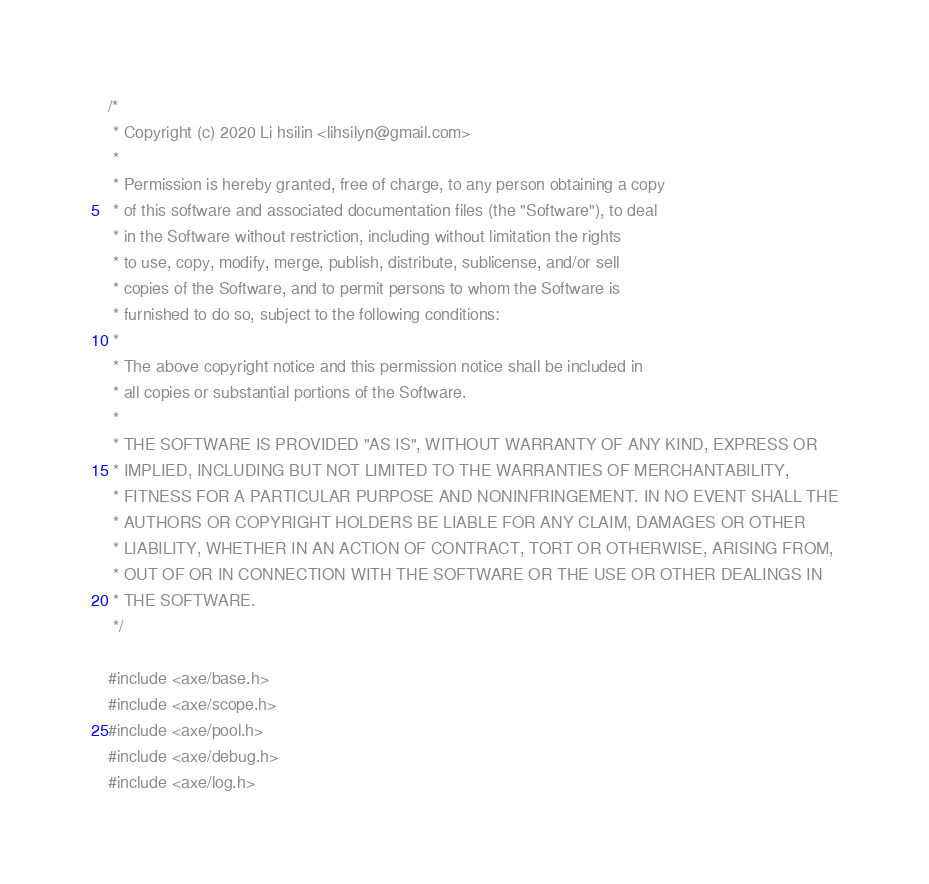Convert code to text. <code><loc_0><loc_0><loc_500><loc_500><_C_>/*
 * Copyright (c) 2020 Li hsilin <lihsilyn@gmail.com>
 *
 * Permission is hereby granted, free of charge, to any person obtaining a copy
 * of this software and associated documentation files (the "Software"), to deal
 * in the Software without restriction, including without limitation the rights
 * to use, copy, modify, merge, publish, distribute, sublicense, and/or sell
 * copies of the Software, and to permit persons to whom the Software is
 * furnished to do so, subject to the following conditions:
 *
 * The above copyright notice and this permission notice shall be included in
 * all copies or substantial portions of the Software.
 *
 * THE SOFTWARE IS PROVIDED "AS IS", WITHOUT WARRANTY OF ANY KIND, EXPRESS OR
 * IMPLIED, INCLUDING BUT NOT LIMITED TO THE WARRANTIES OF MERCHANTABILITY,
 * FITNESS FOR A PARTICULAR PURPOSE AND NONINFRINGEMENT. IN NO EVENT SHALL THE
 * AUTHORS OR COPYRIGHT HOLDERS BE LIABLE FOR ANY CLAIM, DAMAGES OR OTHER
 * LIABILITY, WHETHER IN AN ACTION OF CONTRACT, TORT OR OTHERWISE, ARISING FROM,
 * OUT OF OR IN CONNECTION WITH THE SOFTWARE OR THE USE OR OTHER DEALINGS IN
 * THE SOFTWARE.
 */

#include <axe/base.h>
#include <axe/scope.h>
#include <axe/pool.h>
#include <axe/debug.h>
#include <axe/log.h></code> 